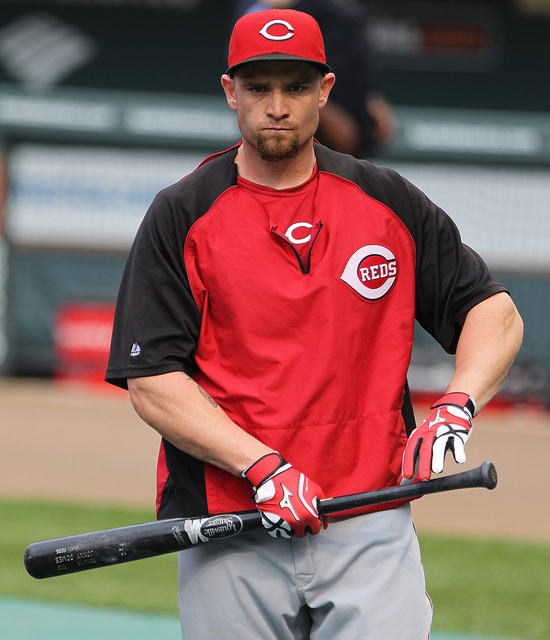Identify and read out the text in this image. REDS C 